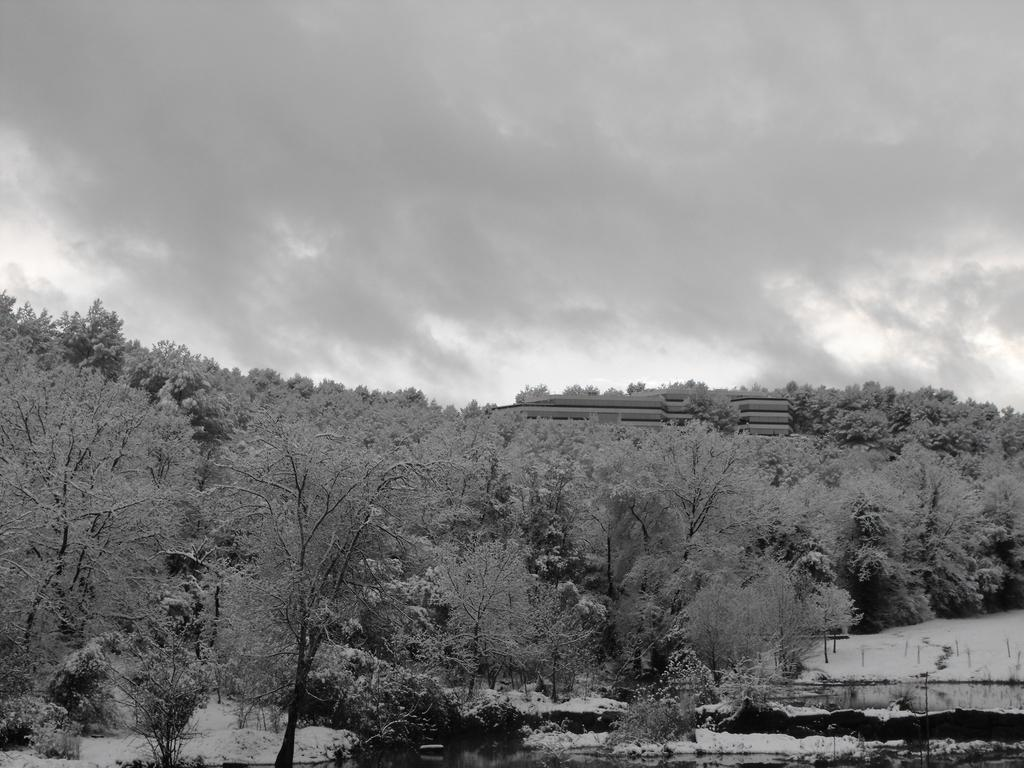What can be seen in the foreground of the image? There are trees, plants, snow, and a building in the foreground of the image. What is located at the bottom of the image? There appears to be a water body at the bottom of the image. What is visible at the top of the image? The sky is visible at the top of the image. How would you describe the sky in the image? The sky is cloudy in the image. How many zebras can be seen enjoying the snow in the image? There are no zebras present in the image. What type of pleasure can be seen in the image? The image does not depict any specific pleasure or activity. 